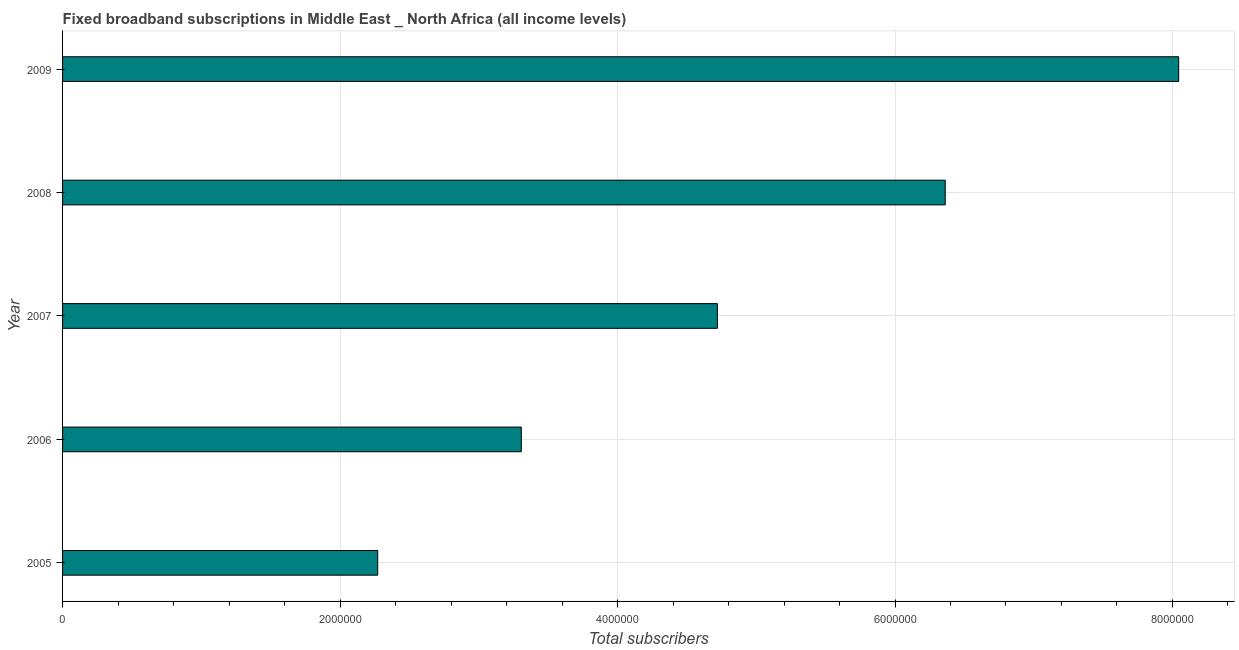Does the graph contain grids?
Make the answer very short. Yes. What is the title of the graph?
Your answer should be compact. Fixed broadband subscriptions in Middle East _ North Africa (all income levels). What is the label or title of the X-axis?
Offer a very short reply. Total subscribers. What is the label or title of the Y-axis?
Keep it short and to the point. Year. What is the total number of fixed broadband subscriptions in 2007?
Make the answer very short. 4.72e+06. Across all years, what is the maximum total number of fixed broadband subscriptions?
Provide a short and direct response. 8.04e+06. Across all years, what is the minimum total number of fixed broadband subscriptions?
Offer a very short reply. 2.27e+06. What is the sum of the total number of fixed broadband subscriptions?
Your answer should be compact. 2.47e+07. What is the difference between the total number of fixed broadband subscriptions in 2006 and 2009?
Your response must be concise. -4.74e+06. What is the average total number of fixed broadband subscriptions per year?
Your response must be concise. 4.94e+06. What is the median total number of fixed broadband subscriptions?
Your answer should be compact. 4.72e+06. In how many years, is the total number of fixed broadband subscriptions greater than 7600000 ?
Your answer should be compact. 1. Do a majority of the years between 2008 and 2005 (inclusive) have total number of fixed broadband subscriptions greater than 7600000 ?
Provide a short and direct response. Yes. What is the ratio of the total number of fixed broadband subscriptions in 2005 to that in 2007?
Keep it short and to the point. 0.48. Is the difference between the total number of fixed broadband subscriptions in 2007 and 2009 greater than the difference between any two years?
Give a very brief answer. No. What is the difference between the highest and the second highest total number of fixed broadband subscriptions?
Provide a short and direct response. 1.68e+06. Is the sum of the total number of fixed broadband subscriptions in 2007 and 2008 greater than the maximum total number of fixed broadband subscriptions across all years?
Provide a succinct answer. Yes. What is the difference between the highest and the lowest total number of fixed broadband subscriptions?
Provide a short and direct response. 5.77e+06. In how many years, is the total number of fixed broadband subscriptions greater than the average total number of fixed broadband subscriptions taken over all years?
Keep it short and to the point. 2. How many bars are there?
Your answer should be compact. 5. Are all the bars in the graph horizontal?
Your answer should be very brief. Yes. How many years are there in the graph?
Make the answer very short. 5. What is the difference between two consecutive major ticks on the X-axis?
Your answer should be very brief. 2.00e+06. Are the values on the major ticks of X-axis written in scientific E-notation?
Offer a terse response. No. What is the Total subscribers in 2005?
Provide a short and direct response. 2.27e+06. What is the Total subscribers in 2006?
Provide a succinct answer. 3.31e+06. What is the Total subscribers of 2007?
Offer a terse response. 4.72e+06. What is the Total subscribers in 2008?
Provide a short and direct response. 6.36e+06. What is the Total subscribers in 2009?
Keep it short and to the point. 8.04e+06. What is the difference between the Total subscribers in 2005 and 2006?
Offer a very short reply. -1.04e+06. What is the difference between the Total subscribers in 2005 and 2007?
Give a very brief answer. -2.45e+06. What is the difference between the Total subscribers in 2005 and 2008?
Provide a succinct answer. -4.09e+06. What is the difference between the Total subscribers in 2005 and 2009?
Your response must be concise. -5.77e+06. What is the difference between the Total subscribers in 2006 and 2007?
Your answer should be compact. -1.41e+06. What is the difference between the Total subscribers in 2006 and 2008?
Ensure brevity in your answer.  -3.06e+06. What is the difference between the Total subscribers in 2006 and 2009?
Keep it short and to the point. -4.74e+06. What is the difference between the Total subscribers in 2007 and 2008?
Provide a short and direct response. -1.64e+06. What is the difference between the Total subscribers in 2007 and 2009?
Offer a terse response. -3.32e+06. What is the difference between the Total subscribers in 2008 and 2009?
Give a very brief answer. -1.68e+06. What is the ratio of the Total subscribers in 2005 to that in 2006?
Give a very brief answer. 0.69. What is the ratio of the Total subscribers in 2005 to that in 2007?
Provide a succinct answer. 0.48. What is the ratio of the Total subscribers in 2005 to that in 2008?
Keep it short and to the point. 0.36. What is the ratio of the Total subscribers in 2005 to that in 2009?
Your answer should be very brief. 0.28. What is the ratio of the Total subscribers in 2006 to that in 2007?
Keep it short and to the point. 0.7. What is the ratio of the Total subscribers in 2006 to that in 2008?
Ensure brevity in your answer.  0.52. What is the ratio of the Total subscribers in 2006 to that in 2009?
Offer a terse response. 0.41. What is the ratio of the Total subscribers in 2007 to that in 2008?
Provide a short and direct response. 0.74. What is the ratio of the Total subscribers in 2007 to that in 2009?
Ensure brevity in your answer.  0.59. What is the ratio of the Total subscribers in 2008 to that in 2009?
Give a very brief answer. 0.79. 